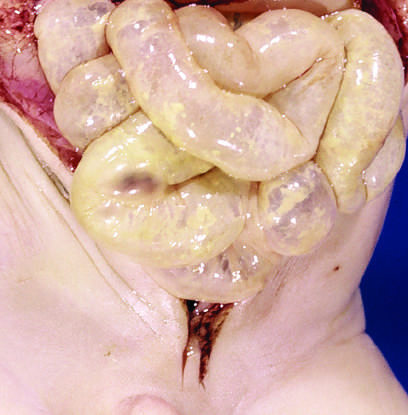what does this appearance imply?
Answer the question using a single word or phrase. Impending perforation 